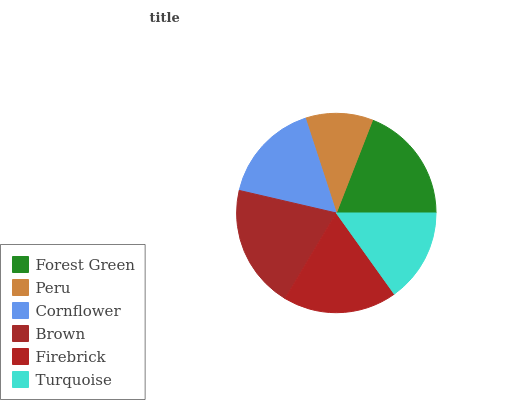Is Peru the minimum?
Answer yes or no. Yes. Is Brown the maximum?
Answer yes or no. Yes. Is Cornflower the minimum?
Answer yes or no. No. Is Cornflower the maximum?
Answer yes or no. No. Is Cornflower greater than Peru?
Answer yes or no. Yes. Is Peru less than Cornflower?
Answer yes or no. Yes. Is Peru greater than Cornflower?
Answer yes or no. No. Is Cornflower less than Peru?
Answer yes or no. No. Is Firebrick the high median?
Answer yes or no. Yes. Is Cornflower the low median?
Answer yes or no. Yes. Is Forest Green the high median?
Answer yes or no. No. Is Brown the low median?
Answer yes or no. No. 